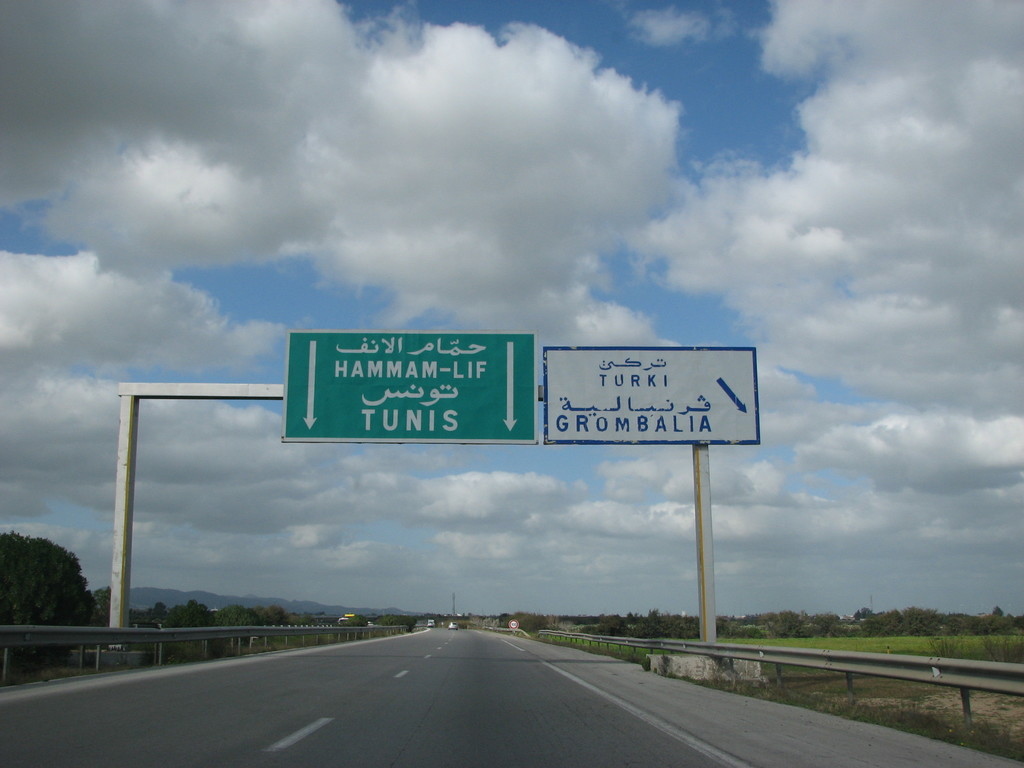If you don't want to arrive at Tunis, which way do you need to go, and where will you end up? According to the road signs in the image, if you don't want to go to Tunis (or Hammam-Lif, which is in the direction of Tunis), you should follow the sign pointing to Grombalia. The blue sign on the right indicates "TURKI GROMBALIA" with an arrow pointing to the right, suggesting that this is the alternative route to take if you don't want to go towards Tunis.

So, to answer your question directly:

1. You need to go right (following the blue sign).
2. You will end up heading towards Grombalia (and possibly Turki, though it's not clear if Turki is a separate destination or part of the name "Turki Grombalia"). 